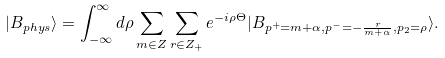<formula> <loc_0><loc_0><loc_500><loc_500>| B _ { p h y s } \rangle = \int _ { - \infty } ^ { \infty } d \rho \sum _ { m \in Z } \sum _ { r \in Z _ { + } } e ^ { - i \rho \Theta } | B _ { p ^ { + } = m + \alpha , p ^ { - } = - \frac { r } { m + \alpha } , p _ { 2 } = \rho } \rangle .</formula> 